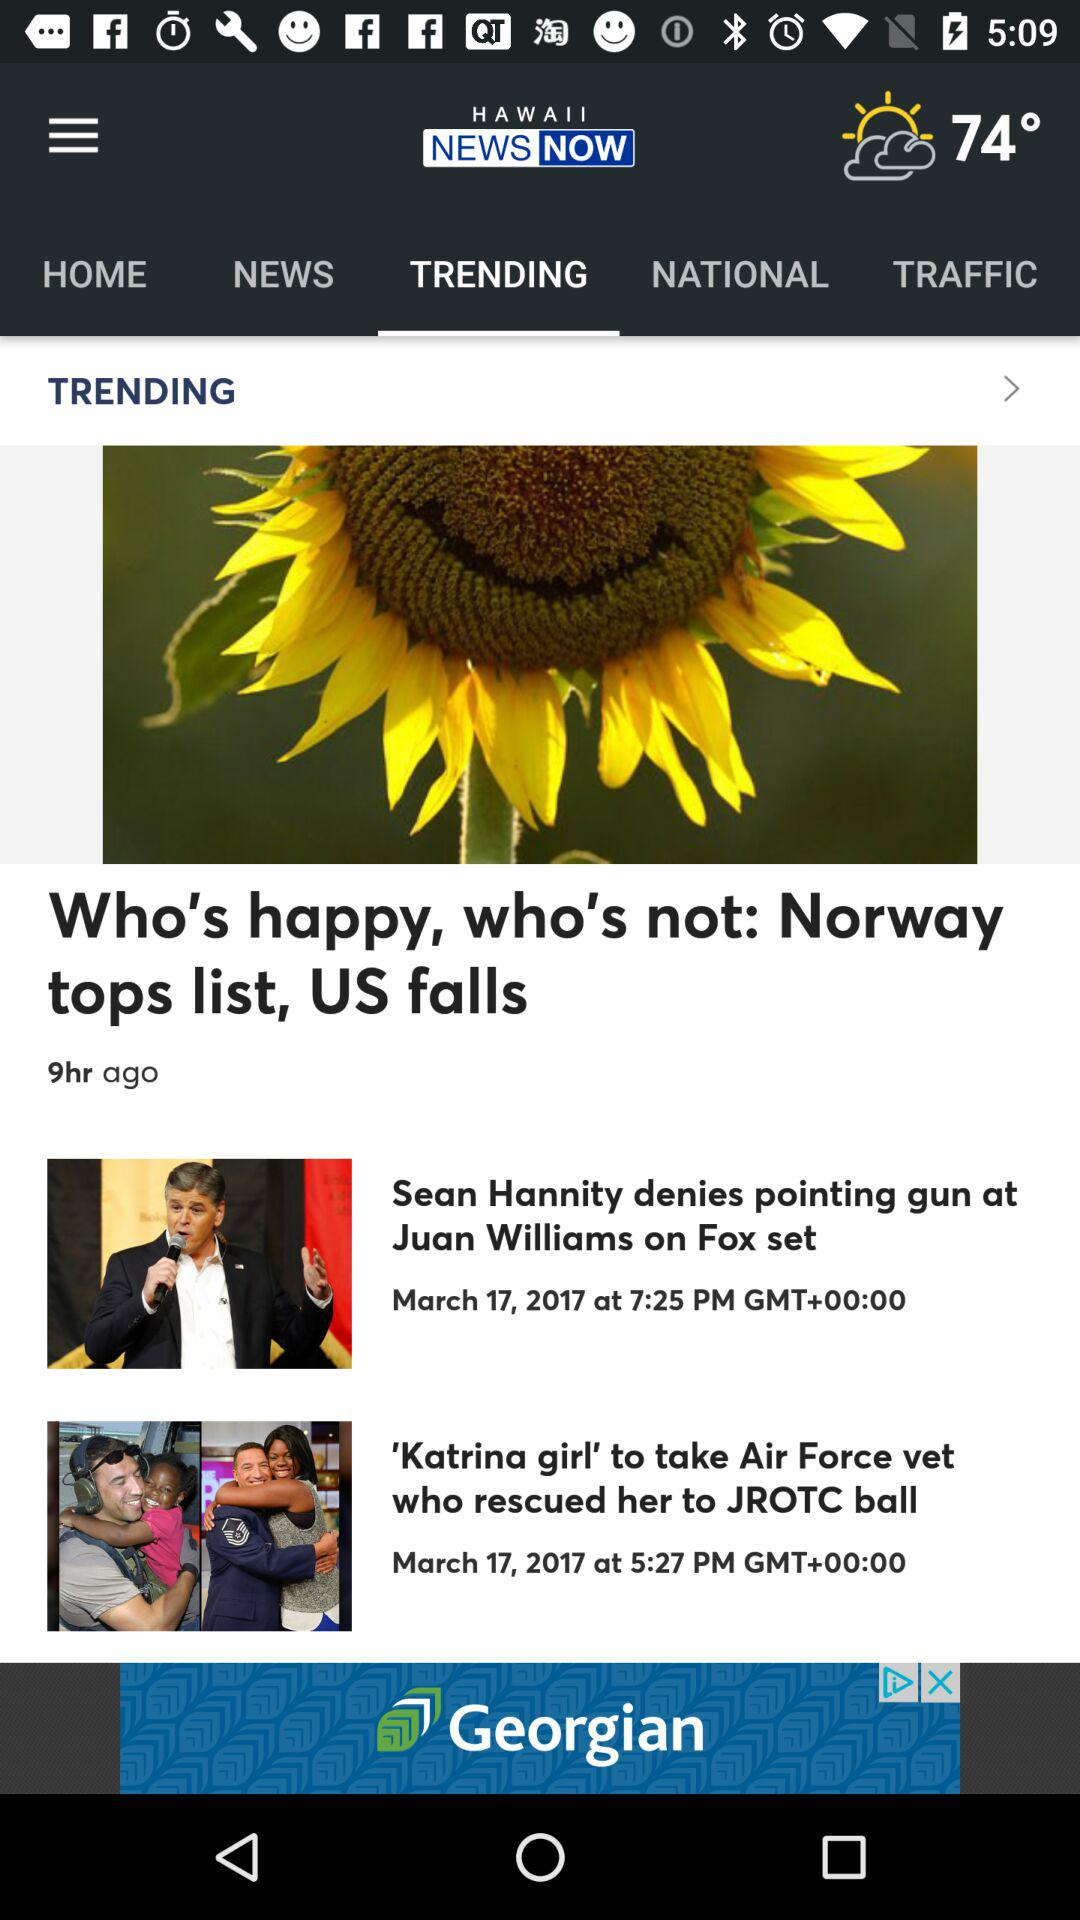What is the temperature? The temperature is 74°. 